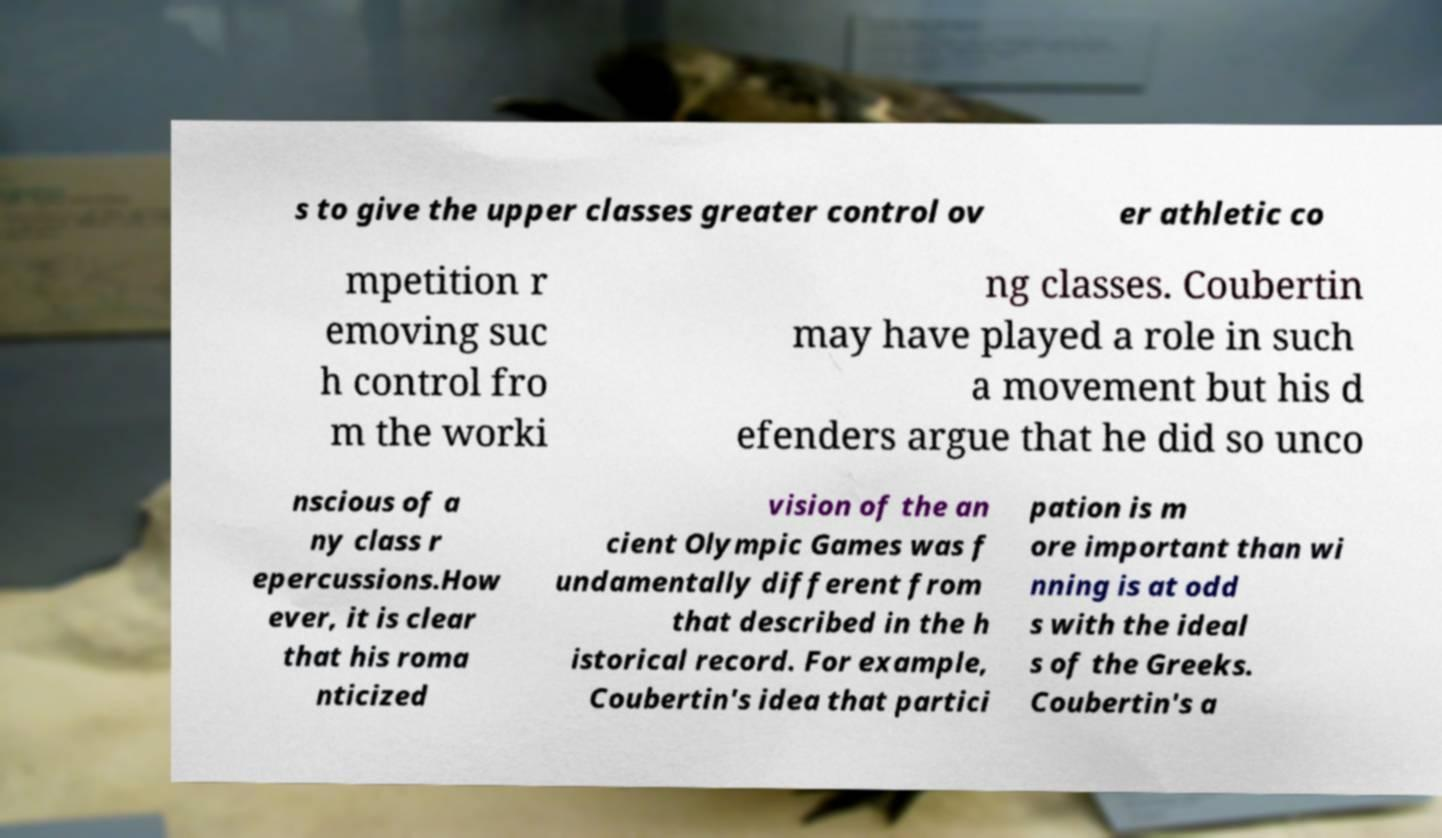What messages or text are displayed in this image? I need them in a readable, typed format. s to give the upper classes greater control ov er athletic co mpetition r emoving suc h control fro m the worki ng classes. Coubertin may have played a role in such a movement but his d efenders argue that he did so unco nscious of a ny class r epercussions.How ever, it is clear that his roma nticized vision of the an cient Olympic Games was f undamentally different from that described in the h istorical record. For example, Coubertin's idea that partici pation is m ore important than wi nning is at odd s with the ideal s of the Greeks. Coubertin's a 